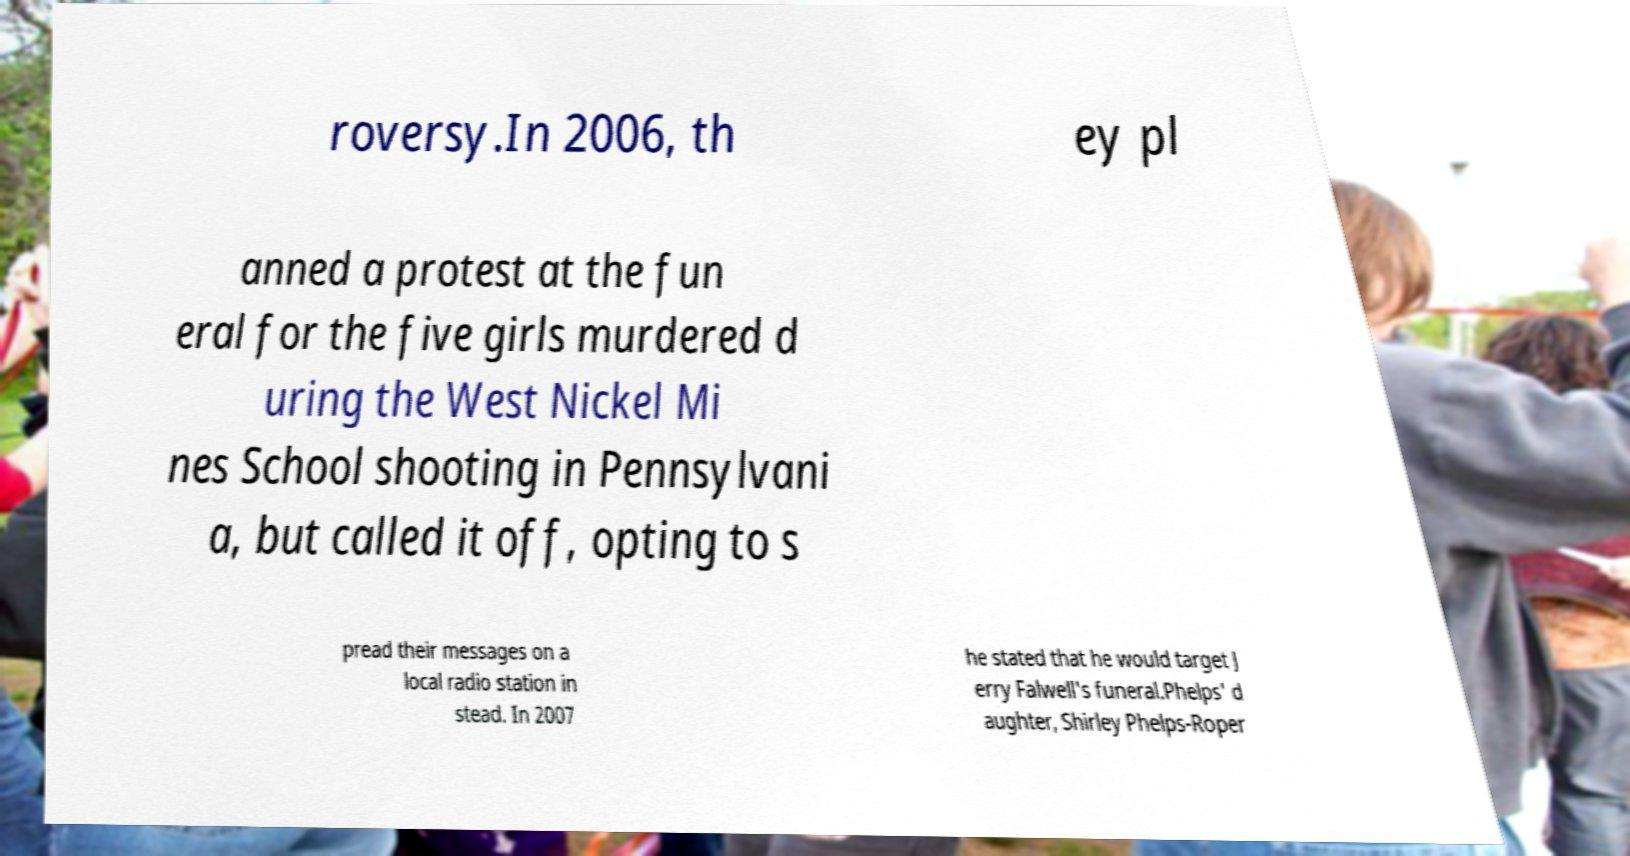Please read and relay the text visible in this image. What does it say? roversy.In 2006, th ey pl anned a protest at the fun eral for the five girls murdered d uring the West Nickel Mi nes School shooting in Pennsylvani a, but called it off, opting to s pread their messages on a local radio station in stead. In 2007 he stated that he would target J erry Falwell's funeral.Phelps' d aughter, Shirley Phelps-Roper 